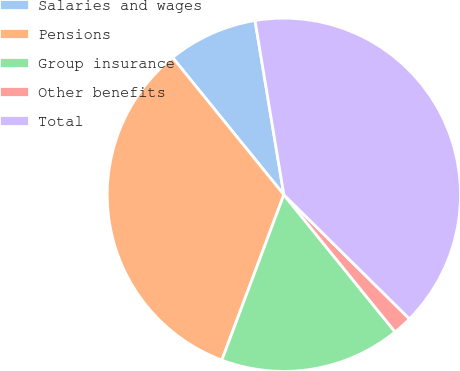Convert chart to OTSL. <chart><loc_0><loc_0><loc_500><loc_500><pie_chart><fcel>Salaries and wages<fcel>Pensions<fcel>Group insurance<fcel>Other benefits<fcel>Total<nl><fcel>8.23%<fcel>33.45%<fcel>16.55%<fcel>1.75%<fcel>40.02%<nl></chart> 